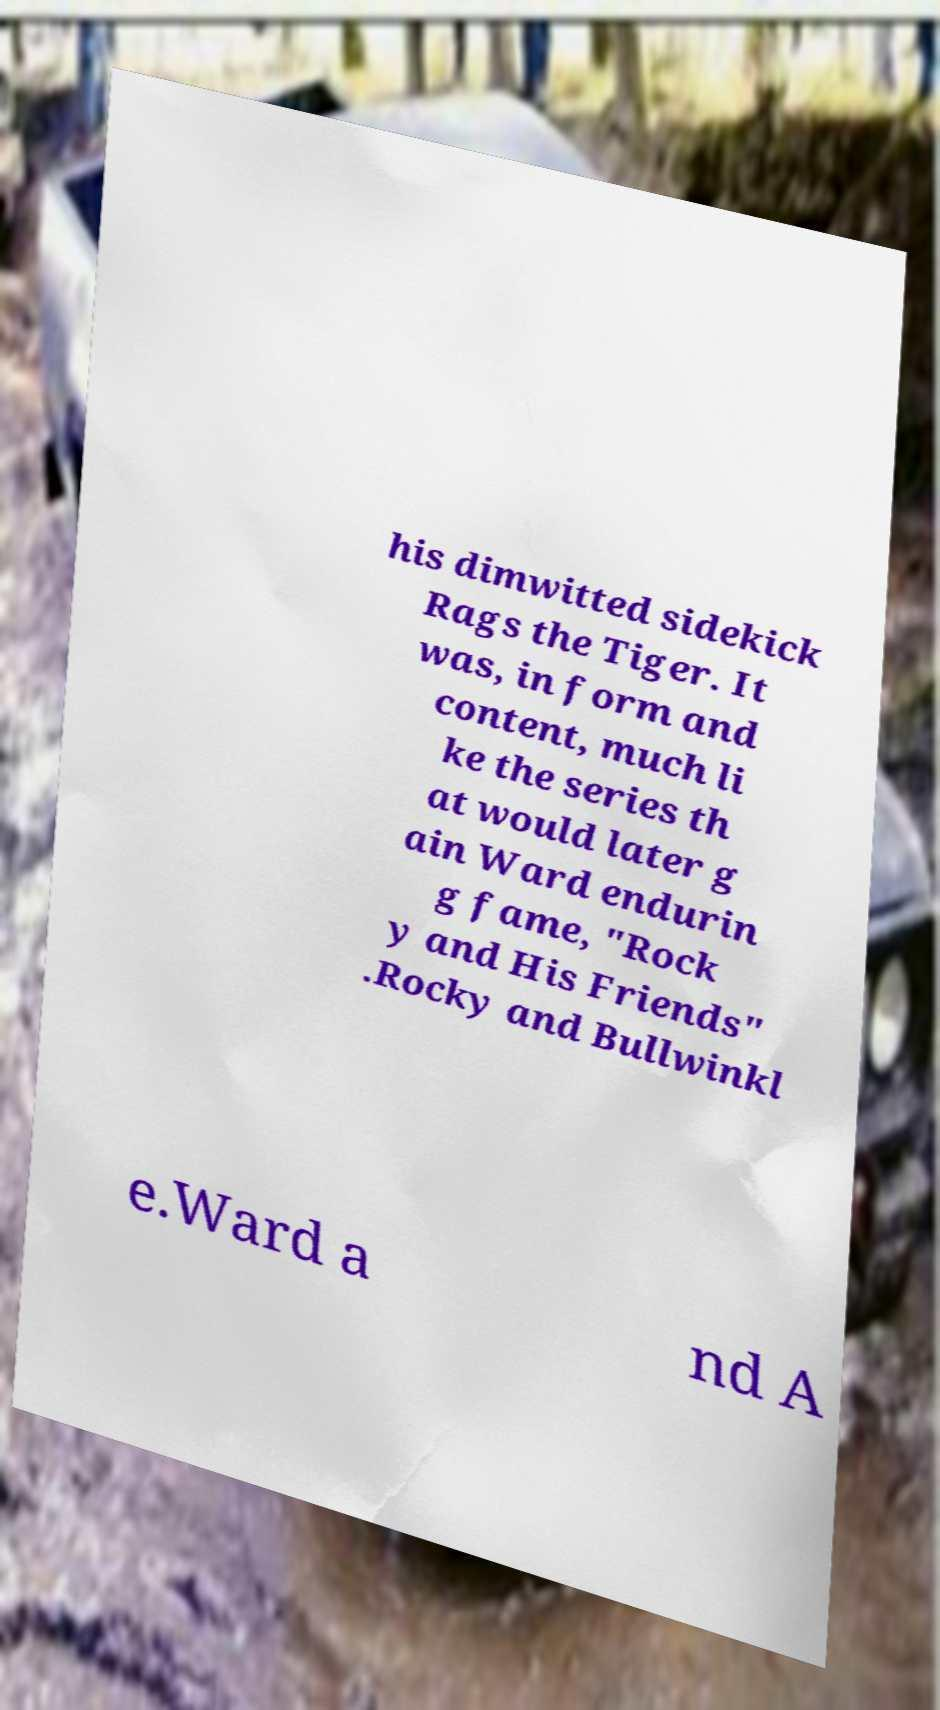For documentation purposes, I need the text within this image transcribed. Could you provide that? his dimwitted sidekick Rags the Tiger. It was, in form and content, much li ke the series th at would later g ain Ward endurin g fame, "Rock y and His Friends" .Rocky and Bullwinkl e.Ward a nd A 